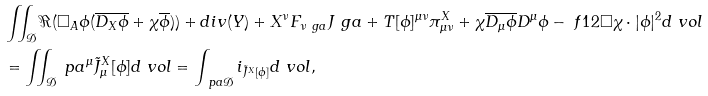<formula> <loc_0><loc_0><loc_500><loc_500>& \iint _ { \mathcal { D } } \Re ( \Box _ { A } \phi ( \overline { D _ { X } \phi } + \chi \overline { \phi } ) ) + d i v ( Y ) + X ^ { \nu } F _ { \nu \ g a } J ^ { \ } g a + T [ \phi ] ^ { \mu \nu } \pi ^ { X } _ { \mu \nu } + \chi \overline { D _ { \mu } \phi } D ^ { \mu } \phi - \ f 1 2 \Box \chi \cdot | \phi | ^ { 2 } d \ v o l \\ & = \iint _ { \mathcal { D } } \ p a ^ { \mu } \tilde { J } ^ { X } _ { \mu } [ \phi ] d \ v o l = \int _ { \ p a \mathcal { D } } i _ { \tilde { J } ^ { X } [ \phi ] } d \ v o l ,</formula> 